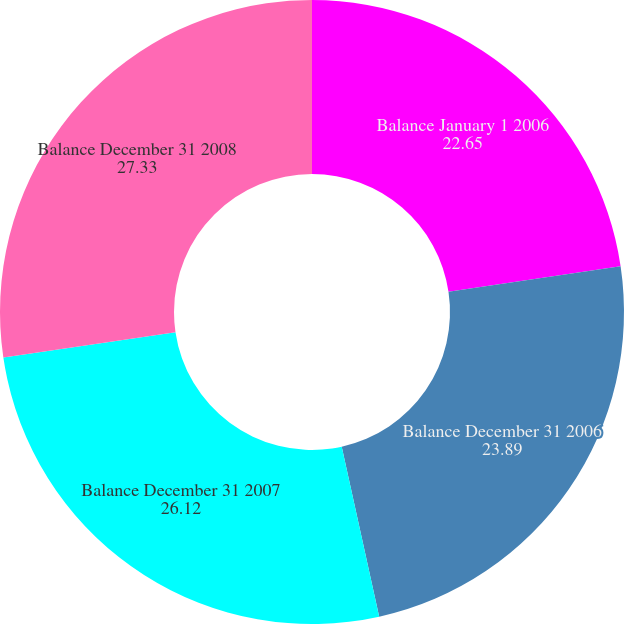Convert chart to OTSL. <chart><loc_0><loc_0><loc_500><loc_500><pie_chart><fcel>Balance January 1 2006<fcel>Balance December 31 2006<fcel>Balance December 31 2007<fcel>Balance December 31 2008<nl><fcel>22.65%<fcel>23.89%<fcel>26.12%<fcel>27.33%<nl></chart> 